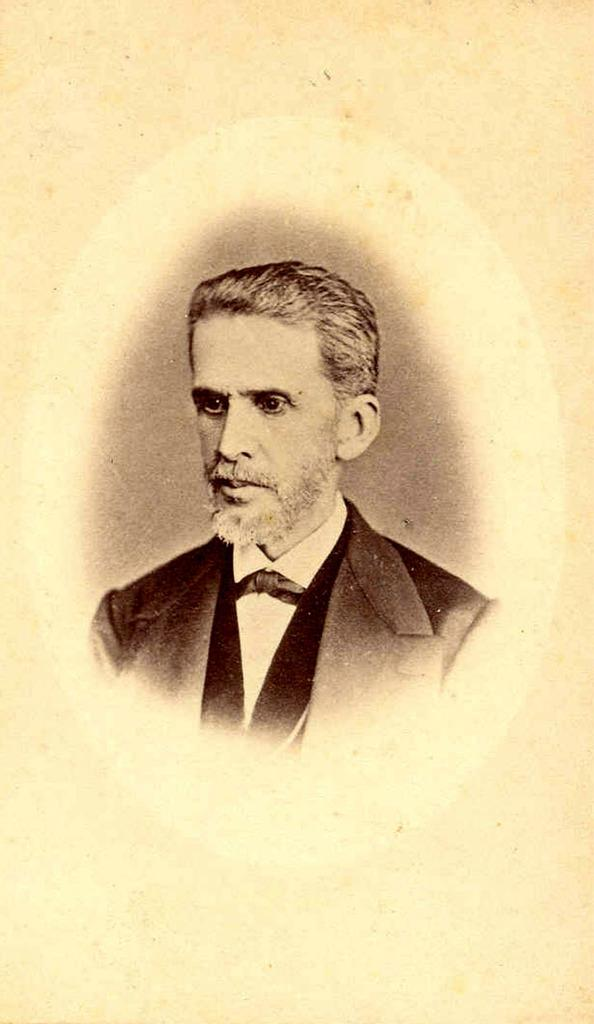Who is the main subject in the image? There is a man in the image. What is the man wearing in the image? The man is wearing a blazer. What is the color of the background in the image? The background of the image has a cream color. What type of pen is the actor using on the island in the image? There is no pen, actor, or island present in the image. 